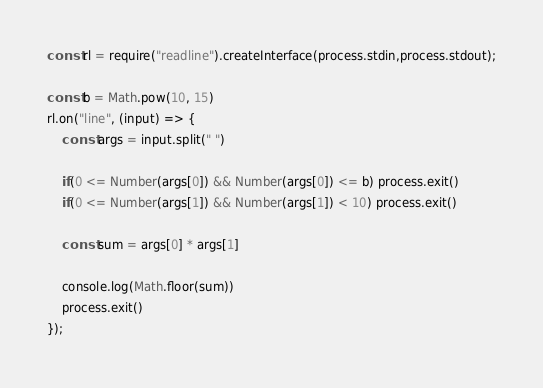Convert code to text. <code><loc_0><loc_0><loc_500><loc_500><_JavaScript_>const rl = require("readline").createInterface(process.stdin,process.stdout);

const b = Math.pow(10, 15)
rl.on("line", (input) => {
    const args = input.split(" ")

    if(0 <= Number(args[0]) && Number(args[0]) <= b) process.exit()
    if(0 <= Number(args[1]) && Number(args[1]) < 10) process.exit()

    const sum = args[0] * args[1]

    console.log(Math.floor(sum))
    process.exit()
});
</code> 